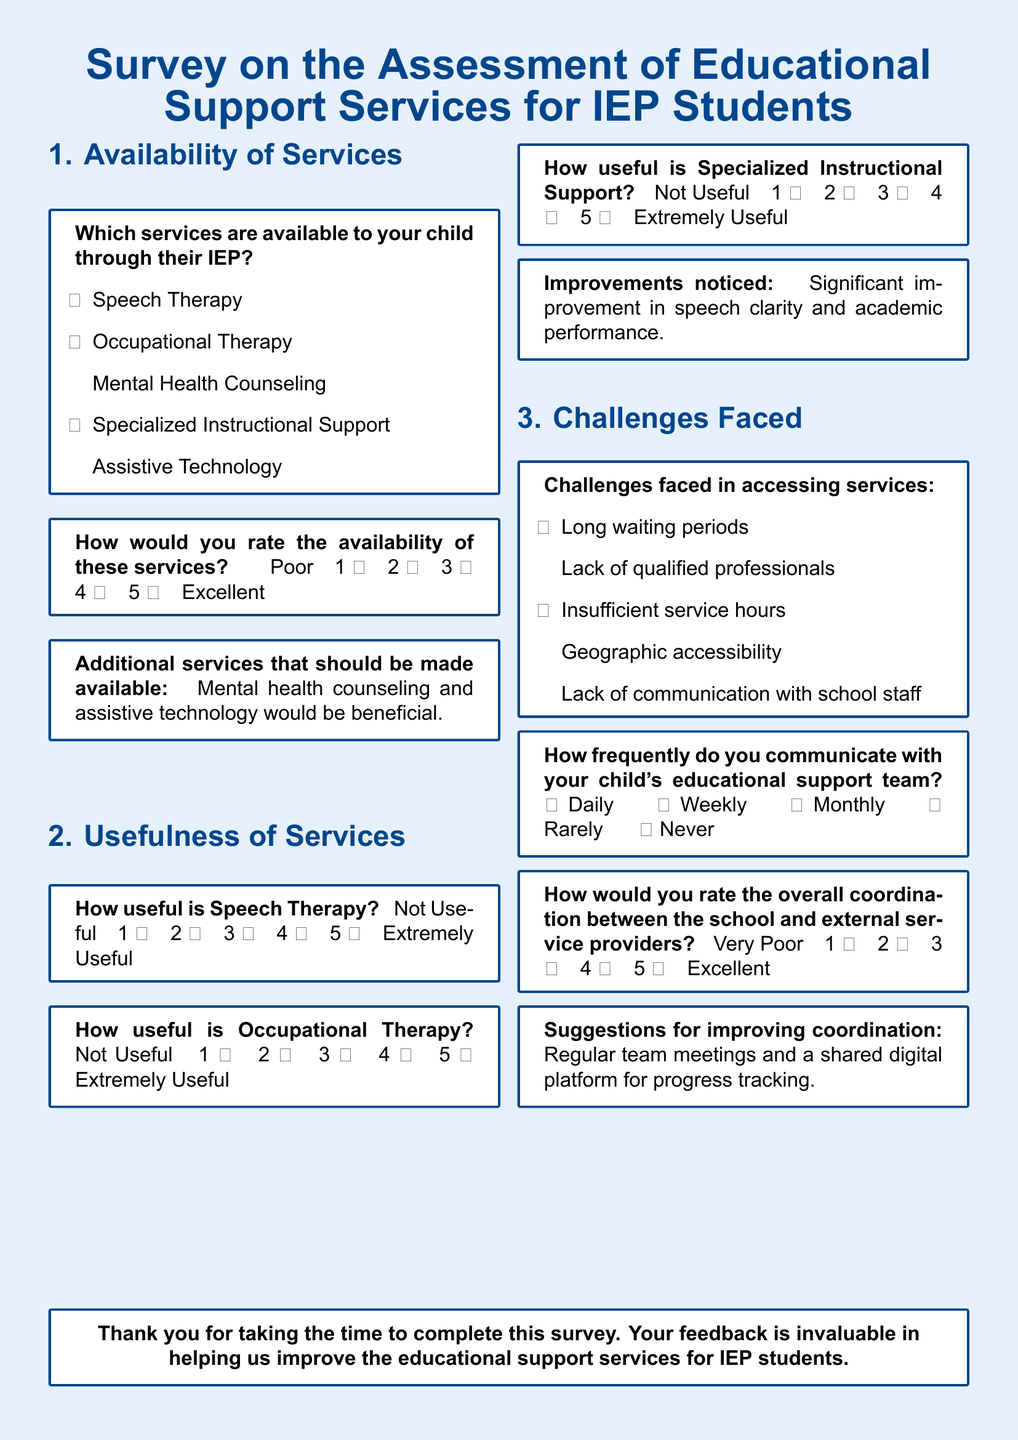What services are available to your child through their IEP? The document lists the available services under "Availability of Services".
Answer: Speech Therapy, Occupational Therapy, Specialized Instructional Support How would you rate the availability of these services? It is mentioned under the "Availability of Services" section with a rating scale included.
Answer: 3 Which additional services are suggested to be made available? The suggestion for additional services is provided in the "Additional services that should be made available" box.
Answer: Mental health counseling and assistive technology How useful is Occupational Therapy? The usefulness of services is rated in the "Usefulness of Services" section.
Answer: 3 What challenges were faced in accessing services? The document lists the challenges faced under "Challenges Faced".
Answer: Long waiting periods, Insufficient service hours How frequently do you communicate with your child's educational support team? This is answered in the "Challenges Faced" section regarding communication frequency.
Answer: Weekly How would you rate the overall coordination between the school and external service providers? The rating is provided in the "Challenges Faced" section of the survey.
Answer: 3 What improvement is mentioned regarding service effectiveness? Improvements are noted in the "Improvements noticed" section of the survey.
Answer: Significant improvement in speech clarity and academic performance 